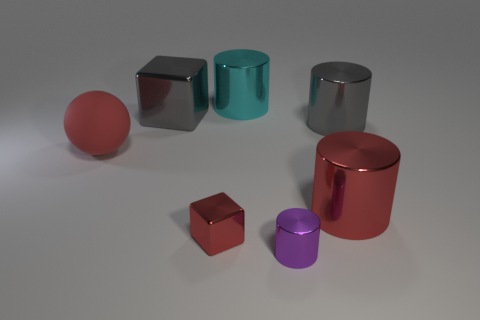Add 2 small blue metal blocks. How many objects exist? 9 Subtract all brown cylinders. Subtract all cyan balls. How many cylinders are left? 4 Subtract all blocks. How many objects are left? 5 Add 3 big cylinders. How many big cylinders are left? 6 Add 6 big red metal blocks. How many big red metal blocks exist? 6 Subtract 0 yellow balls. How many objects are left? 7 Subtract all shiny cylinders. Subtract all large red shiny objects. How many objects are left? 2 